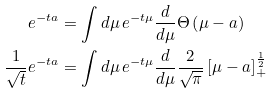<formula> <loc_0><loc_0><loc_500><loc_500>e ^ { - t a } & = \int d \mu \, e ^ { - t \mu } \frac { d } { d \mu } \Theta \left ( \mu - a \right ) \\ \frac { 1 } { \sqrt { t } } e ^ { - t a } & = \int d \mu \, e ^ { - t \mu } \frac { d } { d \mu } \frac { 2 } { \sqrt { \pi } } \left [ \mu - a \right ] _ { + } ^ { \frac { 1 } { 2 } }</formula> 